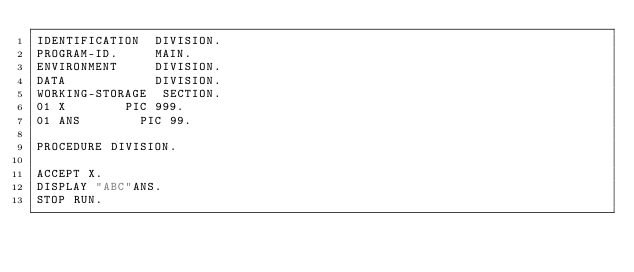Convert code to text. <code><loc_0><loc_0><loc_500><loc_500><_COBOL_>IDENTIFICATION  DIVISION.
PROGRAM-ID.     MAIN.
ENVIRONMENT     DIVISION.
DATA            DIVISION.
WORKING-STORAGE  SECTION.
01 X        PIC 999.
01 ANS		  PIC 99.
      
PROCEDURE DIVISION.
 
ACCEPT X.
DISPLAY "ABC"ANS.
STOP RUN.
</code> 